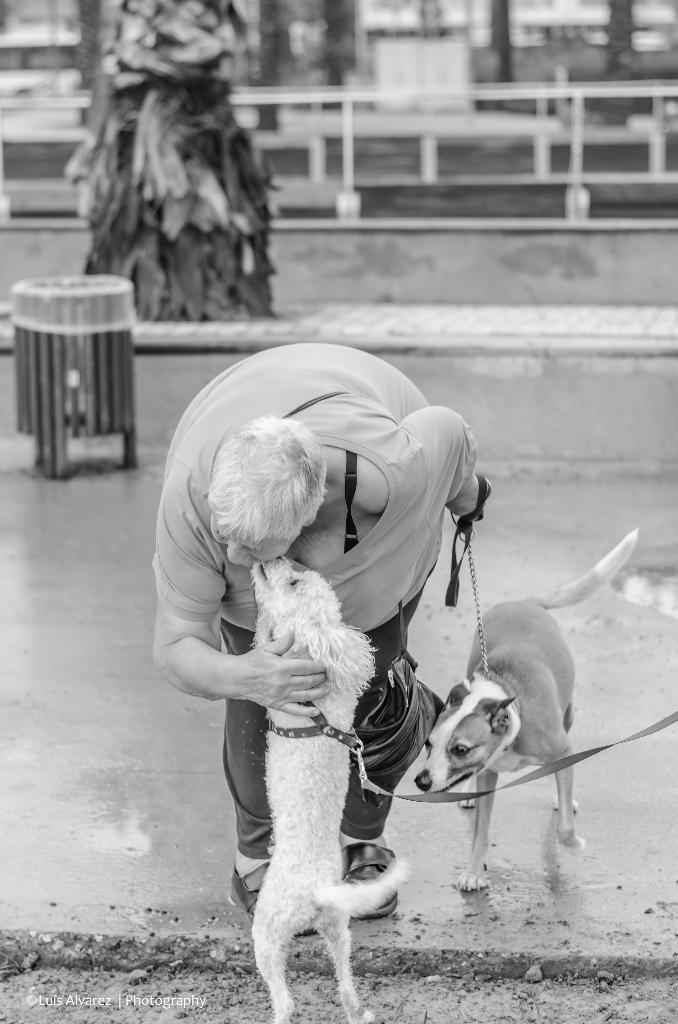Please provide a concise description of this image. In this image, we can see a person wearing clothes and holding a dog with a leash. There is an another dog at the bottom of the image. There is a trash bin on the left side of the image. 